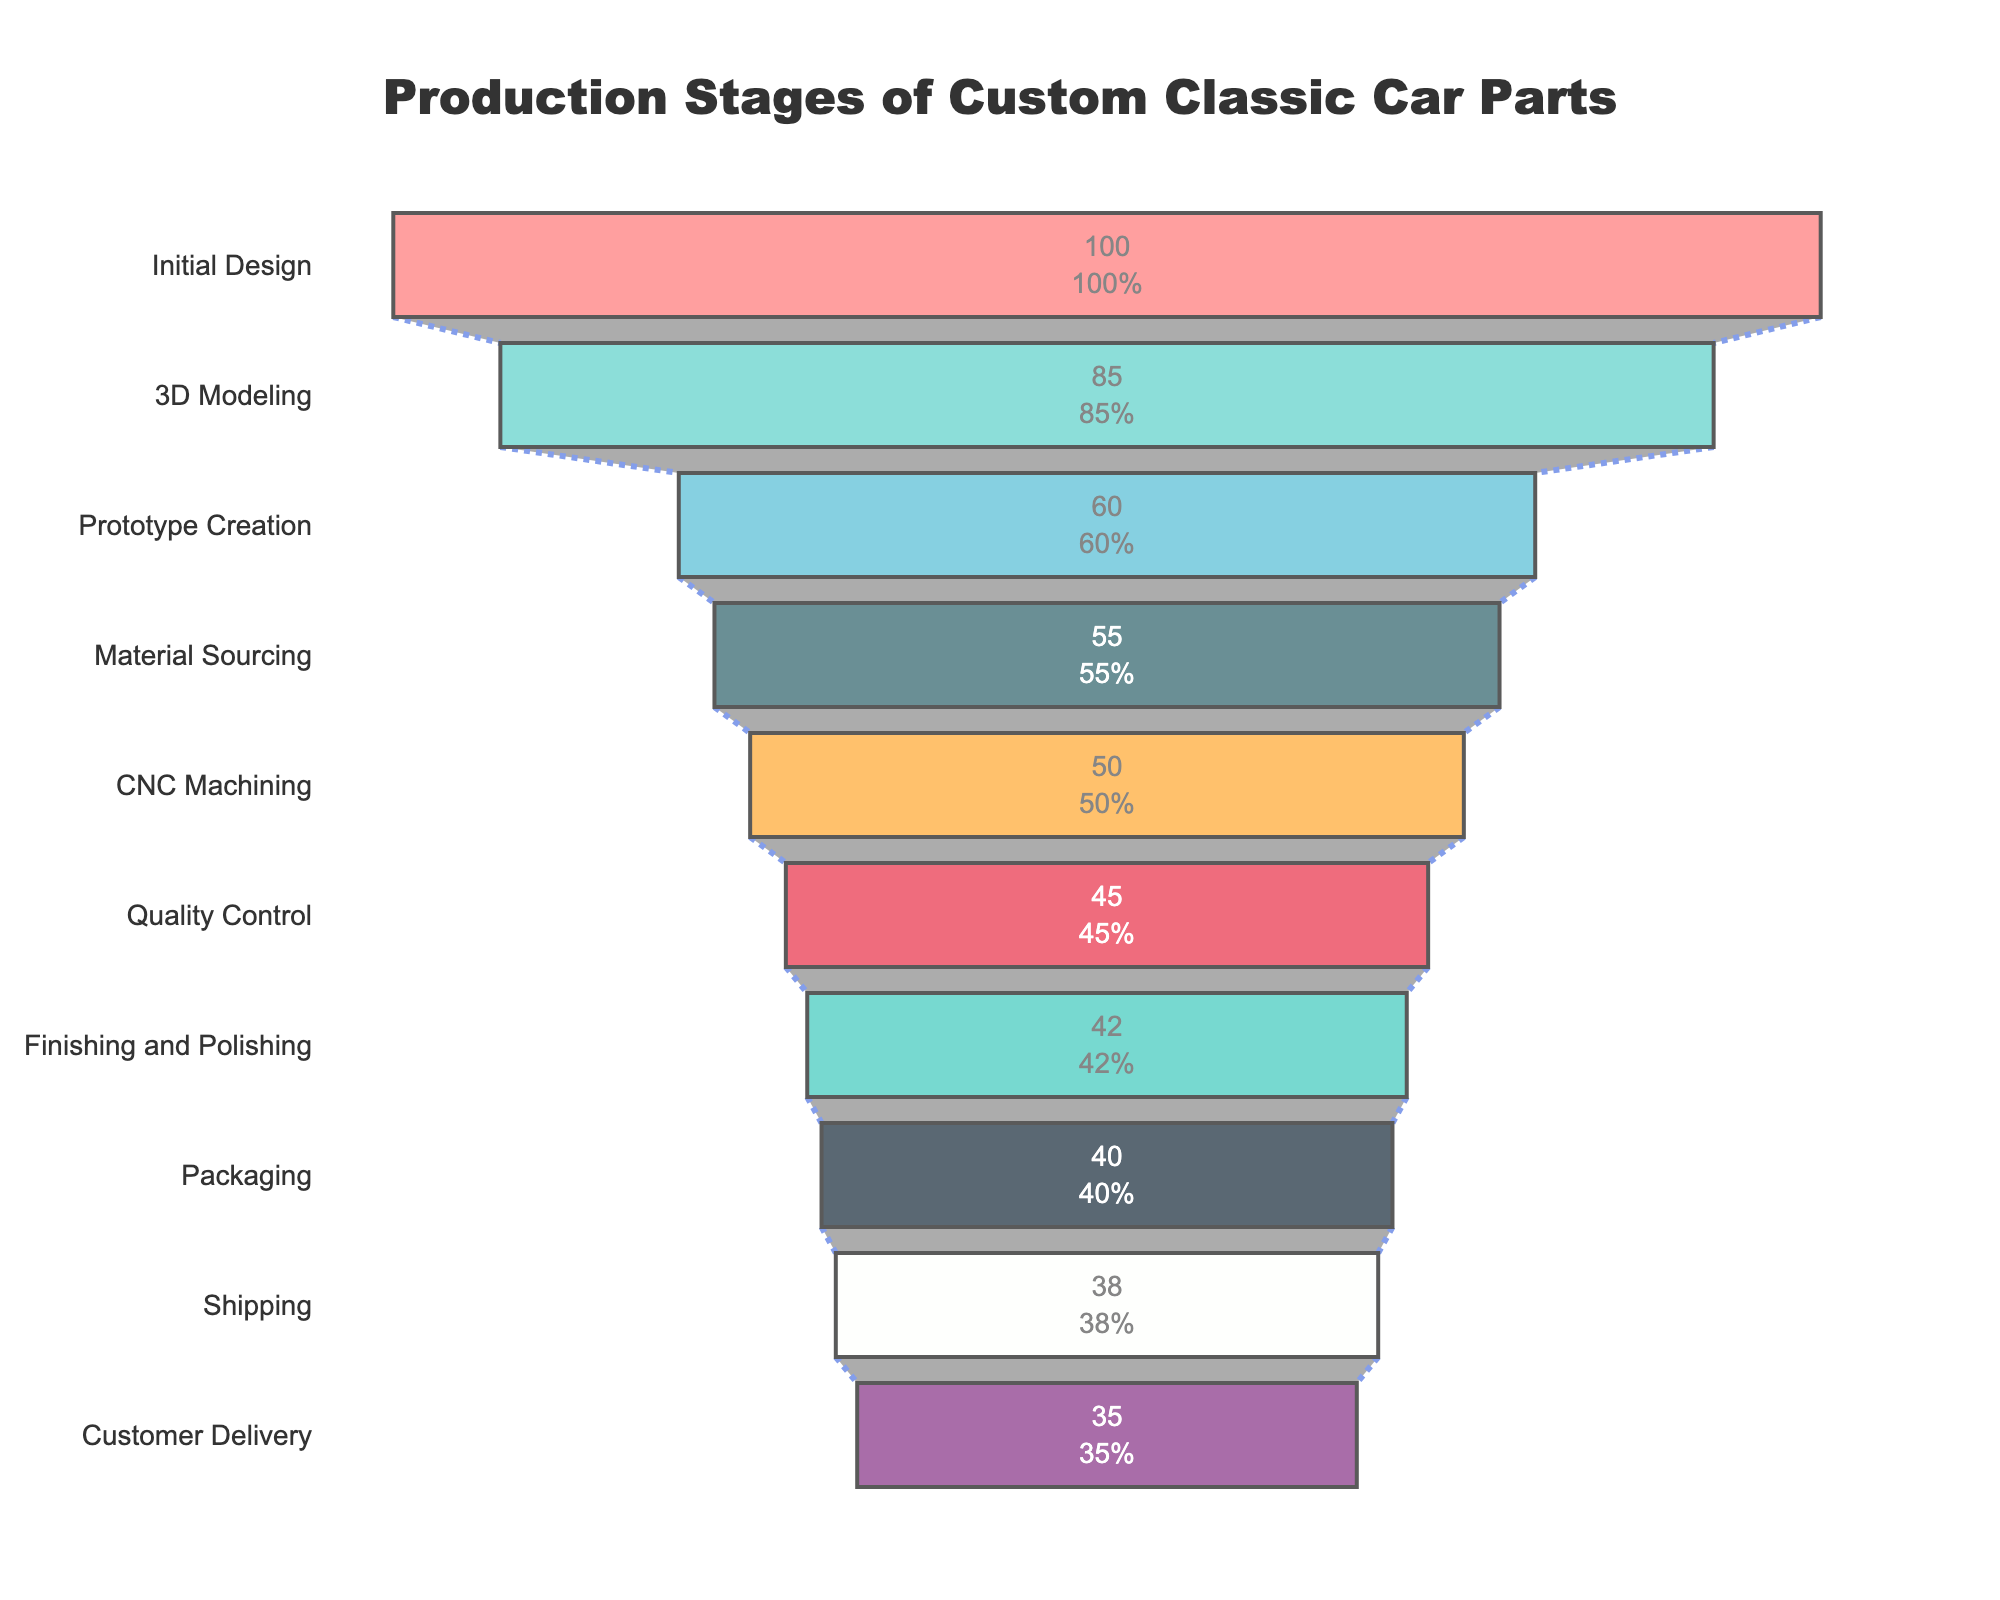What's the title of the chart? The title is located at the top center of the chart and provides an overview of the entire visualization. Here, it reads "Production Stages of Custom Classic Car Parts".
Answer: Production Stages of Custom Classic Car Parts How many parts reach the Shipping stage? The chart shows the number of parts at each stage, with "Shipping" being one of these stages. According to the chart, 38 parts reach the Shipping stage.
Answer: 38 What is the color of the connector line in the funnel chart? The connector line between stages is a distinguishing feature. It is colored royal blue with a dot dash pattern, indicating the sequential flow.
Answer: Royal blue By how many parts does the number drop from Prototype Creation to Material Sourcing? The number of parts at the Prototype Creation stage is 60, and it drops to 55 at Material Sourcing. The decrease is calculated by finding the difference: 60 - 55 = 5 parts.
Answer: 5 parts Which two consecutive stages have the smallest decrease in the number of parts? Compare the differences between each pair of consecutive stages. The smallest difference is between Packaging (40 parts) and Shipping (38 parts), a decrease of 2 parts.
Answer: Packaging to Shipping How many parts have been lost from the Initial Design stage to the Customer Delivery stage in total? Subtract the final number of parts (35 at Customer Delivery) from the initial number (100 at Initial Design) to find the total loss: 100 - 35 = 65 parts.
Answer: 65 parts What is the percentage of parts that make it from CNC Machining to Quality Control? Calculate the percentage by dividing the number of parts reaching Quality Control (45) by those at CNC Machining (50), then multiply by 100: (45 / 50) * 100 = 90%.
Answer: 90% Which stage has the highest initial percentage drop compared to the first stage, and what is that percentage? To find this, note the initial number of parts (100 at Initial Design) and compare each stage to this number. The highest percentage drop occurs at the Prototype Creation stage. The percentage is calculated as: ((100 - 60) / 100) * 100 = 40%.
Answer: Prototype Creation, 40% What are the two most prominent colors used in the funnel chart? The funnel chart uses several colors, but the most prominent colors identified are red and teal.
Answer: Red and teal 